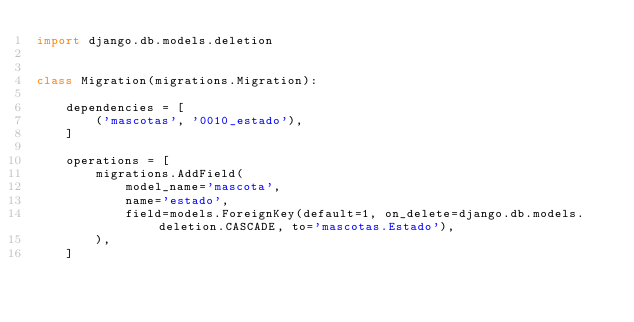Convert code to text. <code><loc_0><loc_0><loc_500><loc_500><_Python_>import django.db.models.deletion


class Migration(migrations.Migration):

    dependencies = [
        ('mascotas', '0010_estado'),
    ]

    operations = [
        migrations.AddField(
            model_name='mascota',
            name='estado',
            field=models.ForeignKey(default=1, on_delete=django.db.models.deletion.CASCADE, to='mascotas.Estado'),
        ),
    ]
</code> 